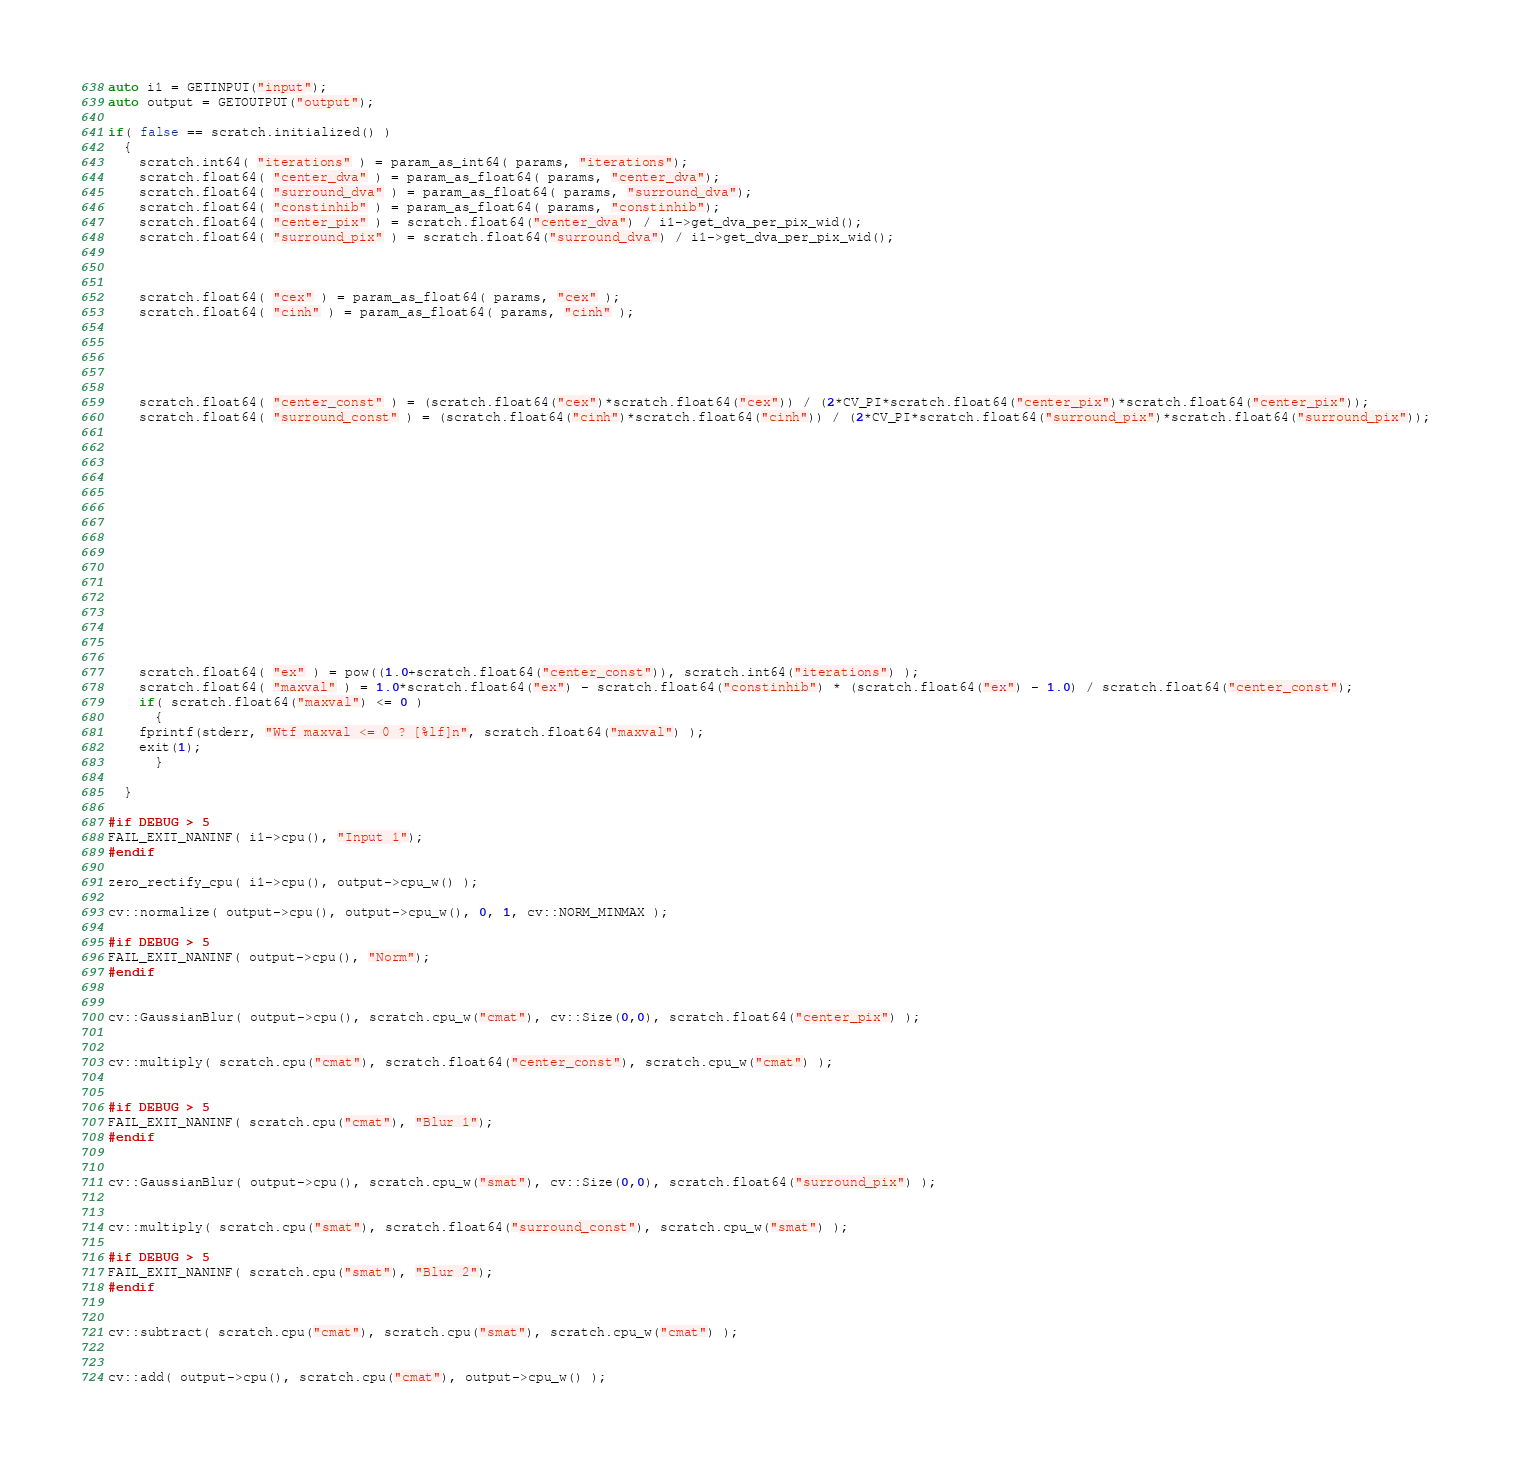<code> <loc_0><loc_0><loc_500><loc_500><_C++_>auto i1 = GETINPUT("input");
auto output = GETOUTPUT("output");

if( false == scratch.initialized() )
  {
    scratch.int64( "iterations" ) = param_as_int64( params, "iterations"); 
    scratch.float64( "center_dva" ) = param_as_float64( params, "center_dva"); 
    scratch.float64( "surround_dva" ) = param_as_float64( params, "surround_dva");
    scratch.float64( "constinhib" ) = param_as_float64( params, "constinhib");
    scratch.float64( "center_pix" ) = scratch.float64("center_dva") / i1->get_dva_per_pix_wid(); 
    scratch.float64( "surround_pix" ) = scratch.float64("surround_dva") / i1->get_dva_per_pix_wid();

  
  
    scratch.float64( "cex" ) = param_as_float64( params, "cex" ); 
    scratch.float64( "cinh" ) = param_as_float64( params, "cinh" ); 
    
    
    
  
    
    scratch.float64( "center_const" ) = (scratch.float64("cex")*scratch.float64("cex")) / (2*CV_PI*scratch.float64("center_pix")*scratch.float64("center_pix")); 
    scratch.float64( "surround_const" ) = (scratch.float64("cinh")*scratch.float64("cinh")) / (2*CV_PI*scratch.float64("surround_pix")*scratch.float64("surround_pix")); 

    
  
    
    
    
    
    
    
    
    
    
    
    
    
    
    scratch.float64( "ex" ) = pow((1.0+scratch.float64("center_const")), scratch.int64("iterations") );
    scratch.float64( "maxval" ) = 1.0*scratch.float64("ex") - scratch.float64("constinhib") * (scratch.float64("ex") - 1.0) / scratch.float64("center_const");
    if( scratch.float64("maxval") <= 0 )
      {
	fprintf(stderr, "Wtf maxval <= 0 ? [%lf]n", scratch.float64("maxval") );
	exit(1);
      }

  }

#if DEBUG > 5
FAIL_EXIT_NANINF( i1->cpu(), "Input 1");
#endif

zero_rectify_cpu( i1->cpu(), output->cpu_w() );

cv::normalize( output->cpu(), output->cpu_w(), 0, 1, cv::NORM_MINMAX );

#if DEBUG > 5
FAIL_EXIT_NANINF( output->cpu(), "Norm");
#endif


cv::GaussianBlur( output->cpu(), scratch.cpu_w("cmat"), cv::Size(0,0), scratch.float64("center_pix") );


cv::multiply( scratch.cpu("cmat"), scratch.float64("center_const"), scratch.cpu_w("cmat") );


#if DEBUG > 5
FAIL_EXIT_NANINF( scratch.cpu("cmat"), "Blur 1");
#endif


cv::GaussianBlur( output->cpu(), scratch.cpu_w("smat"), cv::Size(0,0), scratch.float64("surround_pix") );


cv::multiply( scratch.cpu("smat"), scratch.float64("surround_const"), scratch.cpu_w("smat") );

#if DEBUG > 5
FAIL_EXIT_NANINF( scratch.cpu("smat"), "Blur 2");
#endif
  

cv::subtract( scratch.cpu("cmat"), scratch.cpu("smat"), scratch.cpu_w("cmat") );


cv::add( output->cpu(), scratch.cpu("cmat"), output->cpu_w() );

</code> 